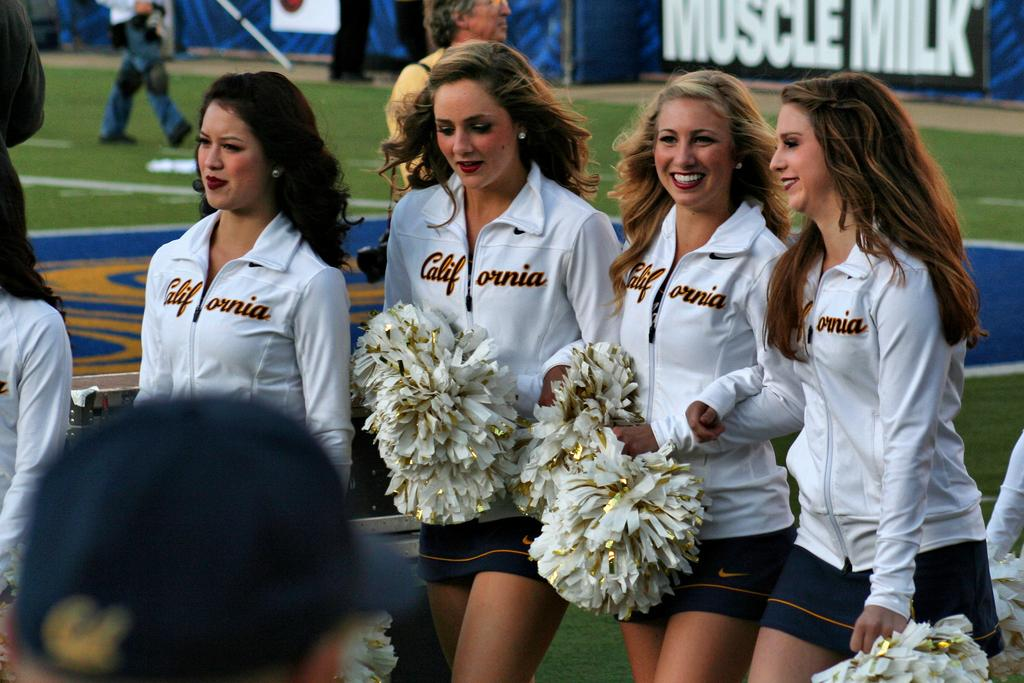<image>
Give a short and clear explanation of the subsequent image. some jackets that say California on them in day 